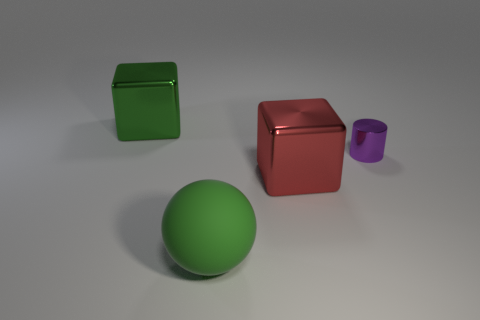Are there any other things that have the same size as the purple cylinder? It appears there are no other objects precisely the same size as the purple cylinder. The green cube is larger, the red cube is slightly so, and the green sphere is also of a different dimension in the given perspective. 